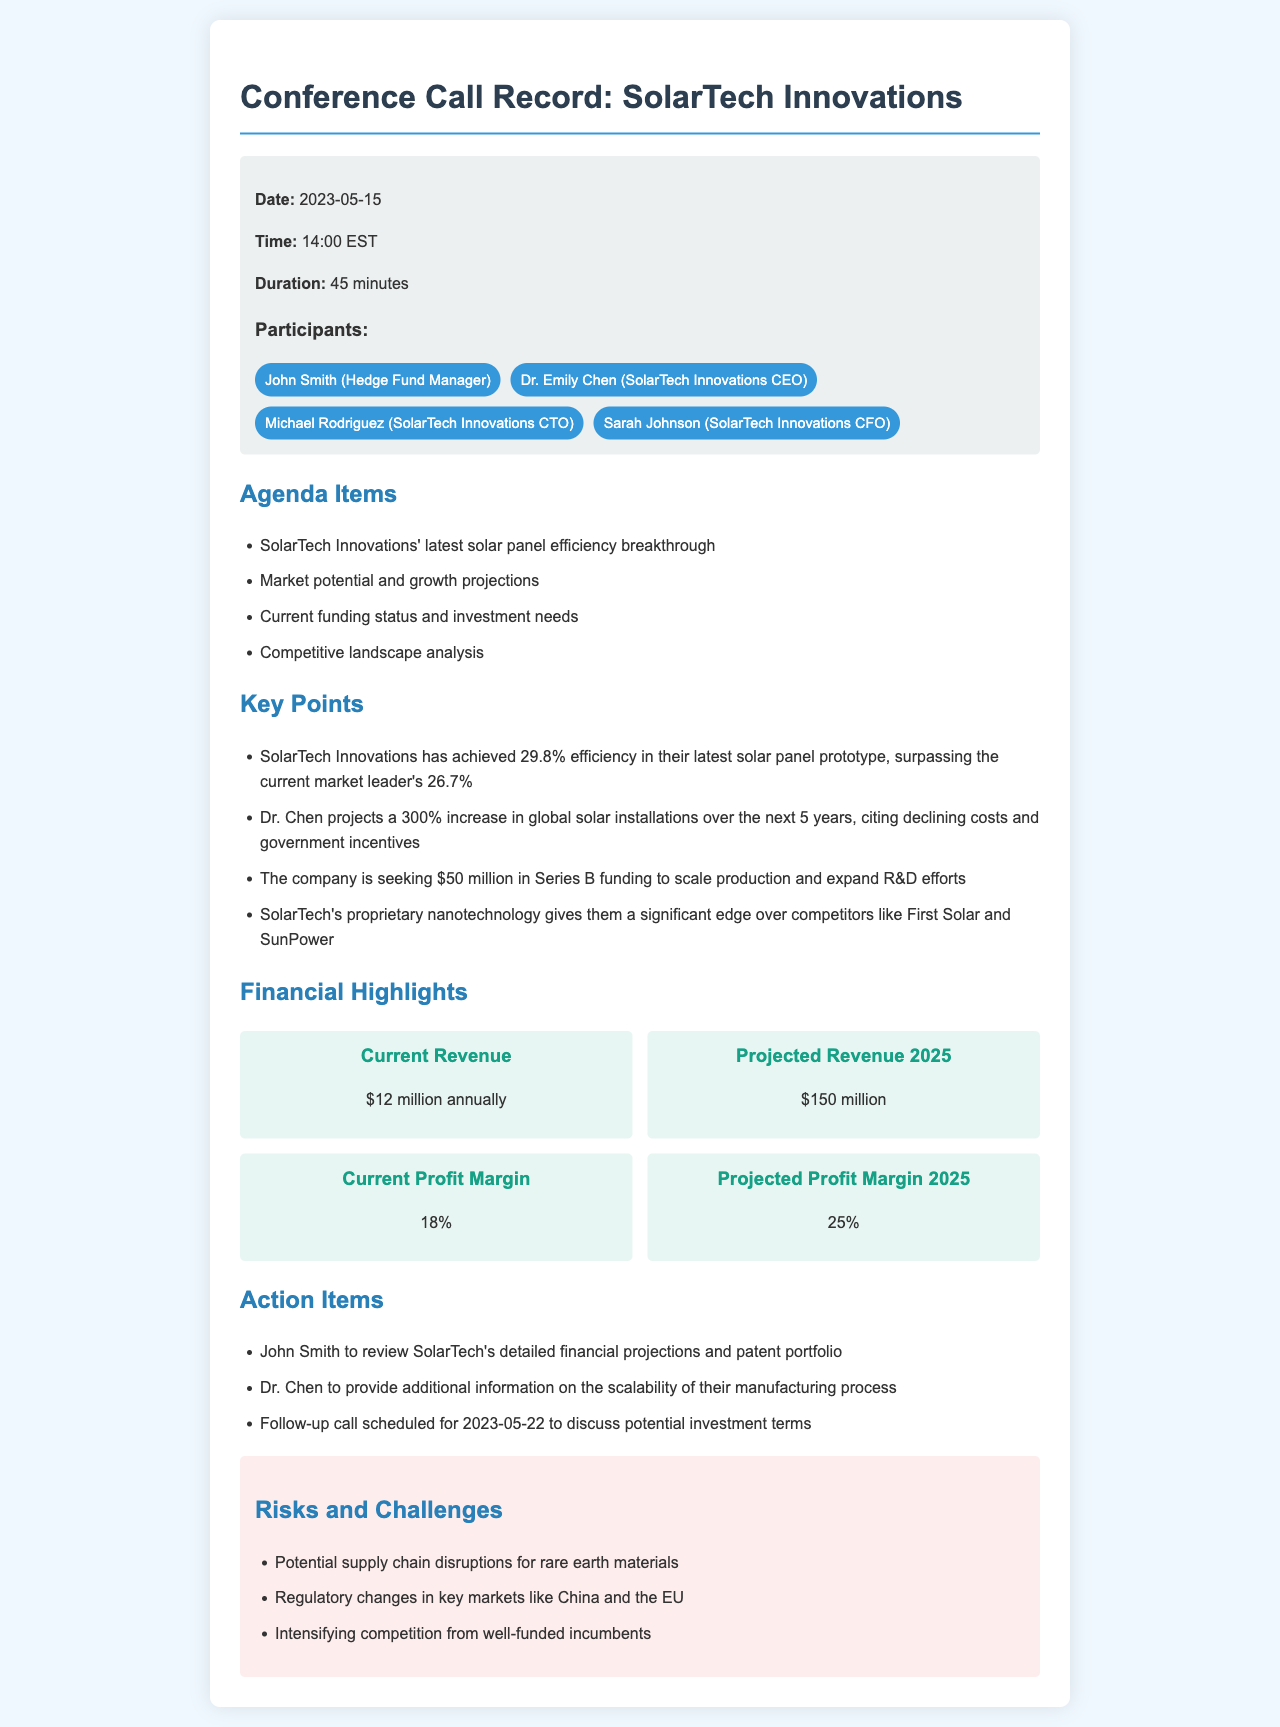What date did the conference call occur? The date of the conference call is mentioned in the call details section of the document.
Answer: 2023-05-15 Who is the CEO of SolarTech Innovations? The CEO's name is listed among the participants in the call.
Answer: Dr. Emily Chen What is the current annual revenue of SolarTech Innovations? The current annual revenue is stated in the financial highlights section of the document.
Answer: $12 million What is the projected profit margin for 2025? The projected profit margin for 2025 is outlined in the financial highlights.
Answer: 25% How much funding is SolarTech seeking in Series B? The amount of funding they are seeking is specified in the key points section of the document.
Answer: $50 million What competitive edge does SolarTech claim to have? The document mentions their proprietary technology in the key points section.
Answer: Nanotechnology What is the follow-up action item for John Smith? John's action item is listed in the action items section of the document.
Answer: Review financial projections and patent portfolio What regulatory challenges could affect SolarTech? The potential regulatory challenges are mentioned in the risks section of the document.
Answer: Changes in key markets like China and the EU 